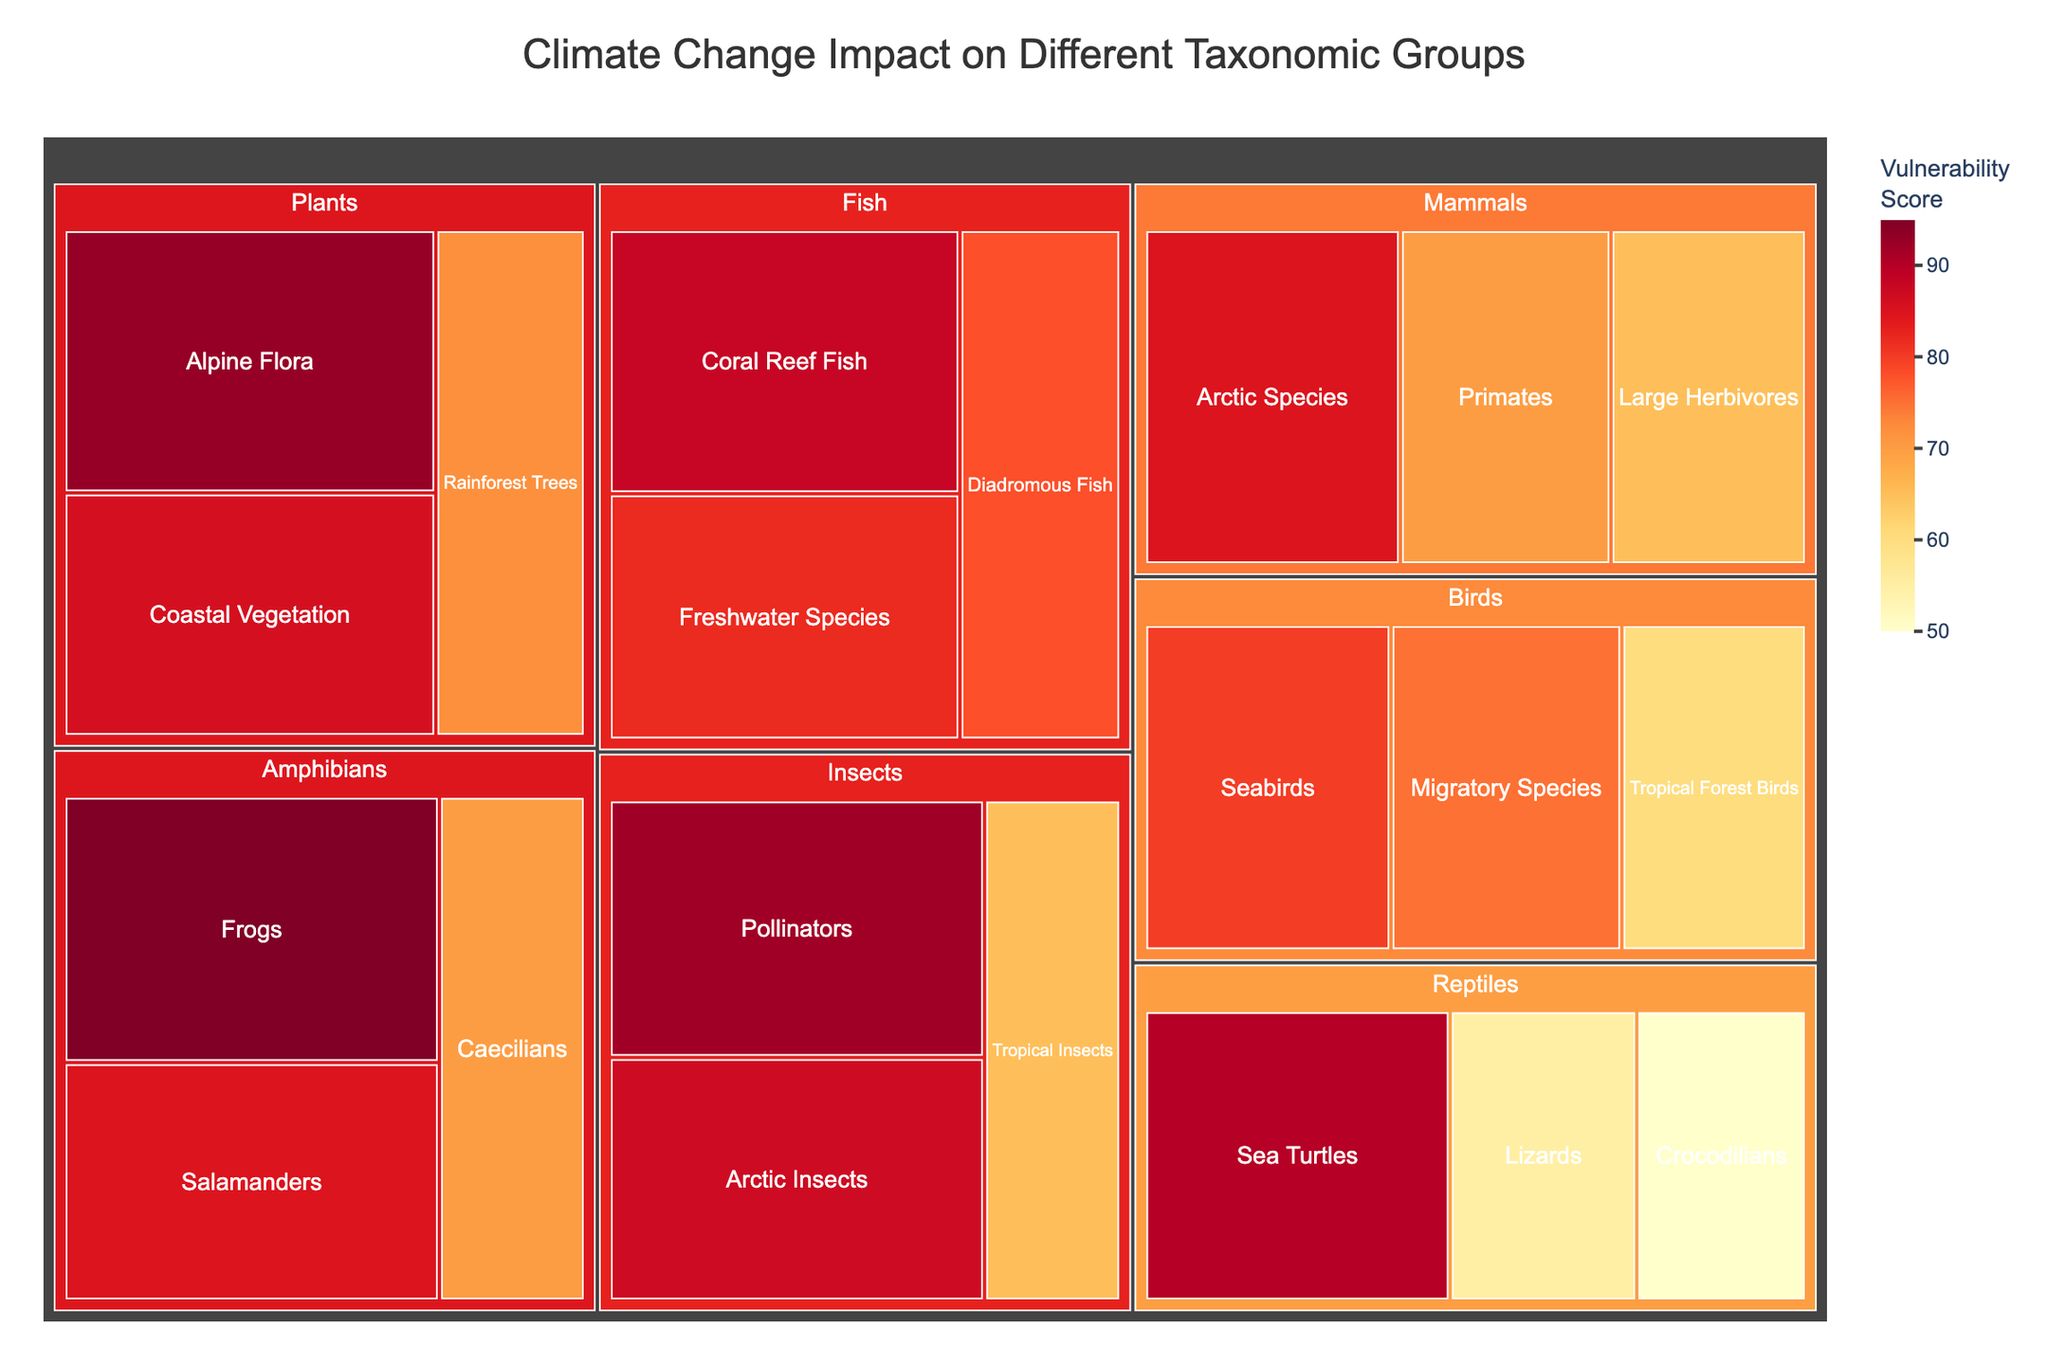What is the title of the treemap? The title is typically displayed prominently at the top of the treemap. Here, the title can be seen as "Climate Change Impact on Different Taxonomic Groups."
Answer: Climate Change Impact on Different Taxonomic Groups Which taxonomic group has the most vulnerable species according to the treemap? By looking at the size and color intensity (darker indicates higher vulnerability) of the sections, the group "Amphibians" stands out with the highest scores. Specifically, the subgroup "Frogs" has the highest vulnerability score of 95.
Answer: Amphibians What is the vulnerability score for Arctic Species under the Mammals group? Locate the "Mammals" section in the treemap and then find the subgroup labeled "Arctic Species" where the vulnerability score is displayed. It is 85.
Answer: 85 How does the vulnerability score of Sea Turtles compare to Coral Reef Fish? First, find the "Reptiles" section and locate the "Sea Turtles" subgroup, then find the "Fish" section and locate the "Coral Reef Fish" subgroup. Sea Turtles have a vulnerability score of 90, while Coral Reef Fish have a score of 88.
Answer: Sea Turtles have a higher vulnerability score than Coral Reef Fish What is the average vulnerability score of the three bird subgroups? List the vulnerability scores of the bird subgroups: Seabirds (80), Migratory Species (75), Tropical Forest Birds (60). Add them up: 80 + 75 + 60 = 215. Divide by 3 to get the average: 215 / 3 = 71.67.
Answer: 71.67 Which taxonomic subgroup under the Insects group has the highest vulnerability score? Locate the "Insects" section in the treemap, then compare the subgroups. Pollinators have the highest score among insects with a score of 92.
Answer: Pollinators What is the sum of the vulnerability scores for Frogs and Salamanders? Locate the "Amphibians" group and find "Frogs" (95) and "Salamanders" (85). Add the scores together: 95 + 85 = 180.
Answer: 180 Which subgroup in the Mammals group has the lowest vulnerability score? In the "Mammals" section, compare the scores of Arctic Species (85), Primates (70), and Large Herbivores (65). Large Herbivores have the lowest score of 65.
Answer: Large Herbivores What is the difference in vulnerability scores between Arctic Insects and Arctic Species? Find the "Insects" section and locate "Arctic Insects" with a score of 87. In the "Mammals" section, locate "Arctic Species" with a score of 85. Calculate the difference: 87 - 85 = 2.
Answer: 2 Which taxonomic subgroup has the highest vulnerability score in the entire treemap? By examining all subgroups, Frogs under the Amphibians group have the highest vulnerability score, which is 95.
Answer: Frogs 